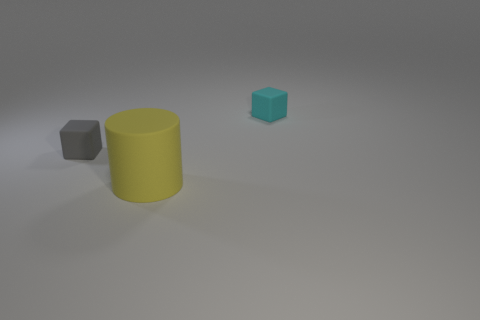Are there any other things that are the same size as the yellow rubber cylinder?
Make the answer very short. No. The block to the left of the object that is right of the yellow rubber thing is made of what material?
Your answer should be very brief. Rubber. The rubber object that is both right of the gray thing and in front of the tiny cyan matte cube has what shape?
Provide a short and direct response. Cylinder. Is the number of tiny cyan rubber objects that are on the left side of the small gray thing less than the number of blue rubber things?
Your answer should be compact. No. There is a thing that is in front of the gray rubber object; how big is it?
Your answer should be compact. Large. The other rubber object that is the same shape as the small cyan matte object is what color?
Your answer should be compact. Gray. How many rubber cylinders are the same color as the big rubber object?
Keep it short and to the point. 0. Are there any other things that have the same shape as the yellow object?
Provide a succinct answer. No. There is a rubber cube that is to the left of the thing that is in front of the gray block; is there a tiny gray thing that is behind it?
Make the answer very short. No. What number of tiny blue cubes are the same material as the small gray object?
Give a very brief answer. 0. 